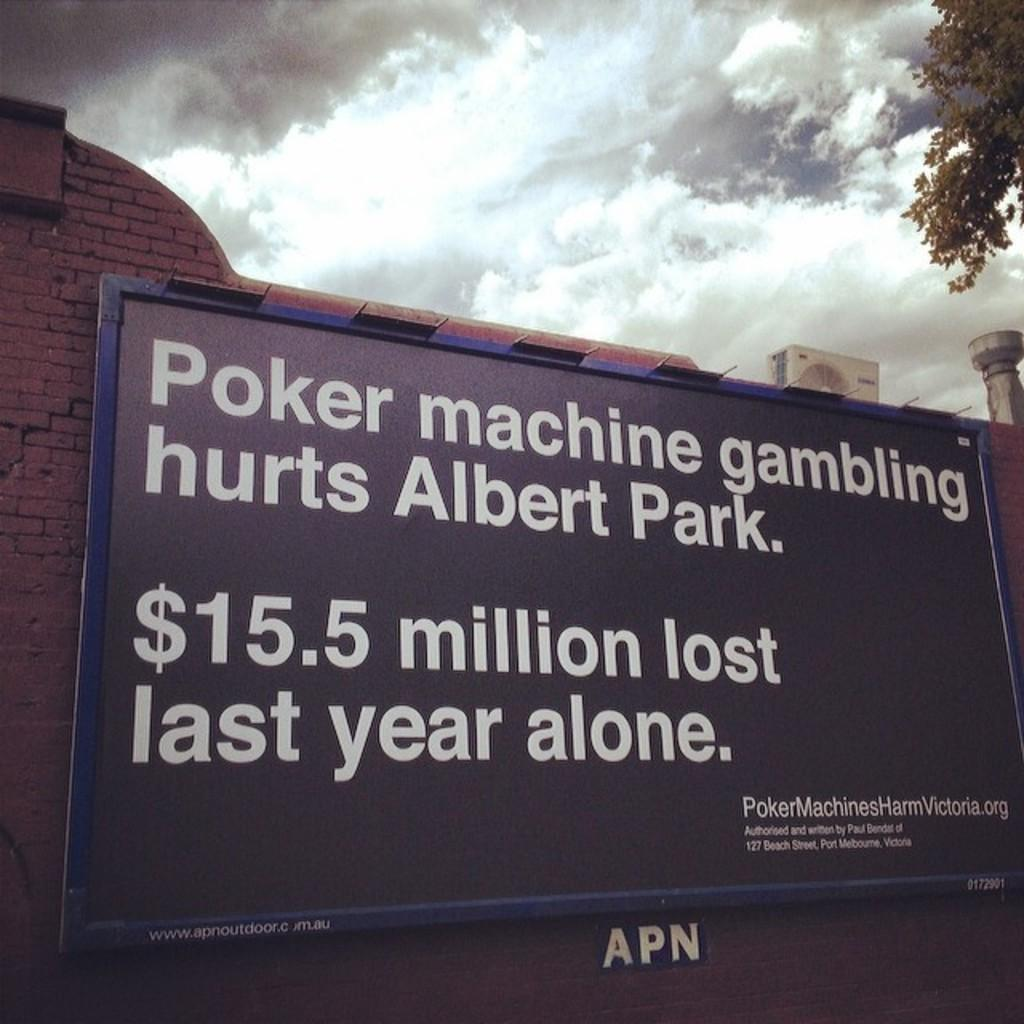Provide a one-sentence caption for the provided image. large sign on a brick wall stating that albert park lost $15.5 million to poker machine gambling last year. 